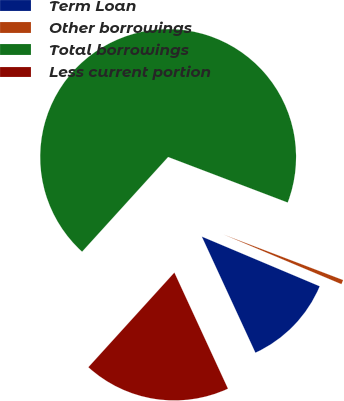Convert chart. <chart><loc_0><loc_0><loc_500><loc_500><pie_chart><fcel>Term Loan<fcel>Other borrowings<fcel>Total borrowings<fcel>Less current portion<nl><fcel>11.77%<fcel>0.56%<fcel>69.05%<fcel>18.62%<nl></chart> 